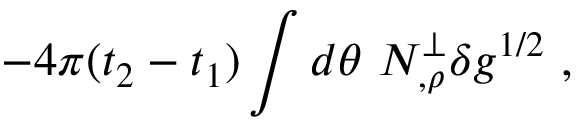<formula> <loc_0><loc_0><loc_500><loc_500>- 4 \pi ( t _ { 2 } - t _ { 1 } ) \int d \theta \ N _ { , \rho } ^ { \perp } \delta g ^ { 1 / 2 } \ ,</formula> 